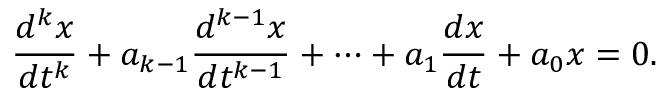<formula> <loc_0><loc_0><loc_500><loc_500>{ \frac { d ^ { k } x } { d t ^ { k } } } + a _ { k - 1 } { \frac { d ^ { k - 1 } x } { d t ^ { k - 1 } } } + \cdots + a _ { 1 } { \frac { d x } { d t } } + a _ { 0 } x = 0 .</formula> 